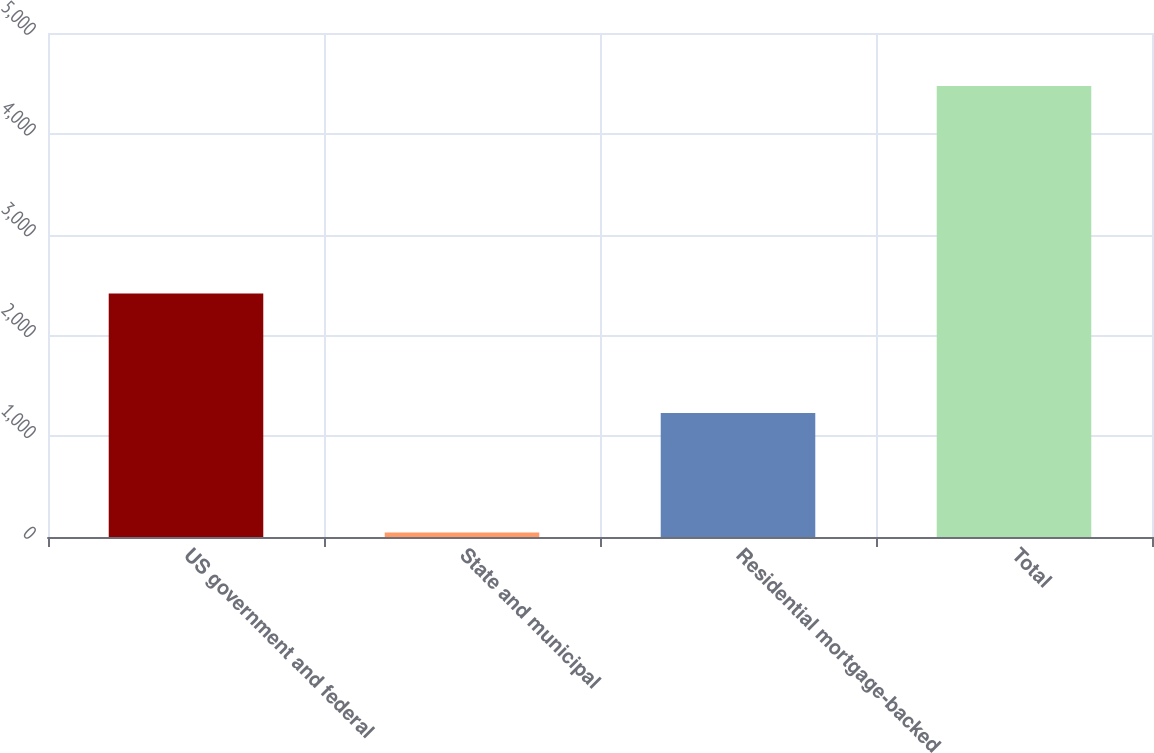Convert chart to OTSL. <chart><loc_0><loc_0><loc_500><loc_500><bar_chart><fcel>US government and federal<fcel>State and municipal<fcel>Residential mortgage-backed<fcel>Total<nl><fcel>2416<fcel>44<fcel>1231<fcel>4473<nl></chart> 